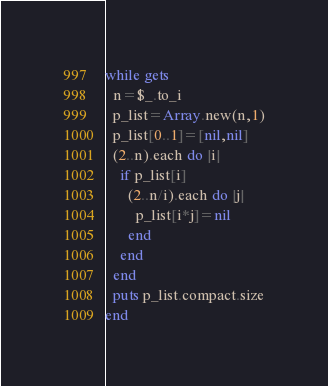<code> <loc_0><loc_0><loc_500><loc_500><_Ruby_>while gets
  n=$_.to_i
  p_list=Array.new(n,1)
  p_list[0..1]=[nil,nil]
  (2..n).each do |i|
    if p_list[i]
      (2..n/i).each do |j|
        p_list[i*j]=nil
      end
    end
  end
  puts p_list.compact.size
end</code> 